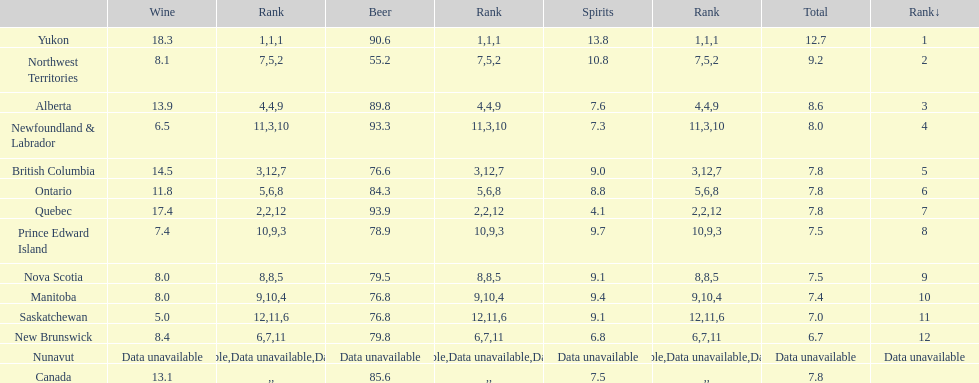Inform me of the region that consumed over 15 liters of wine. Yukon, Quebec. 